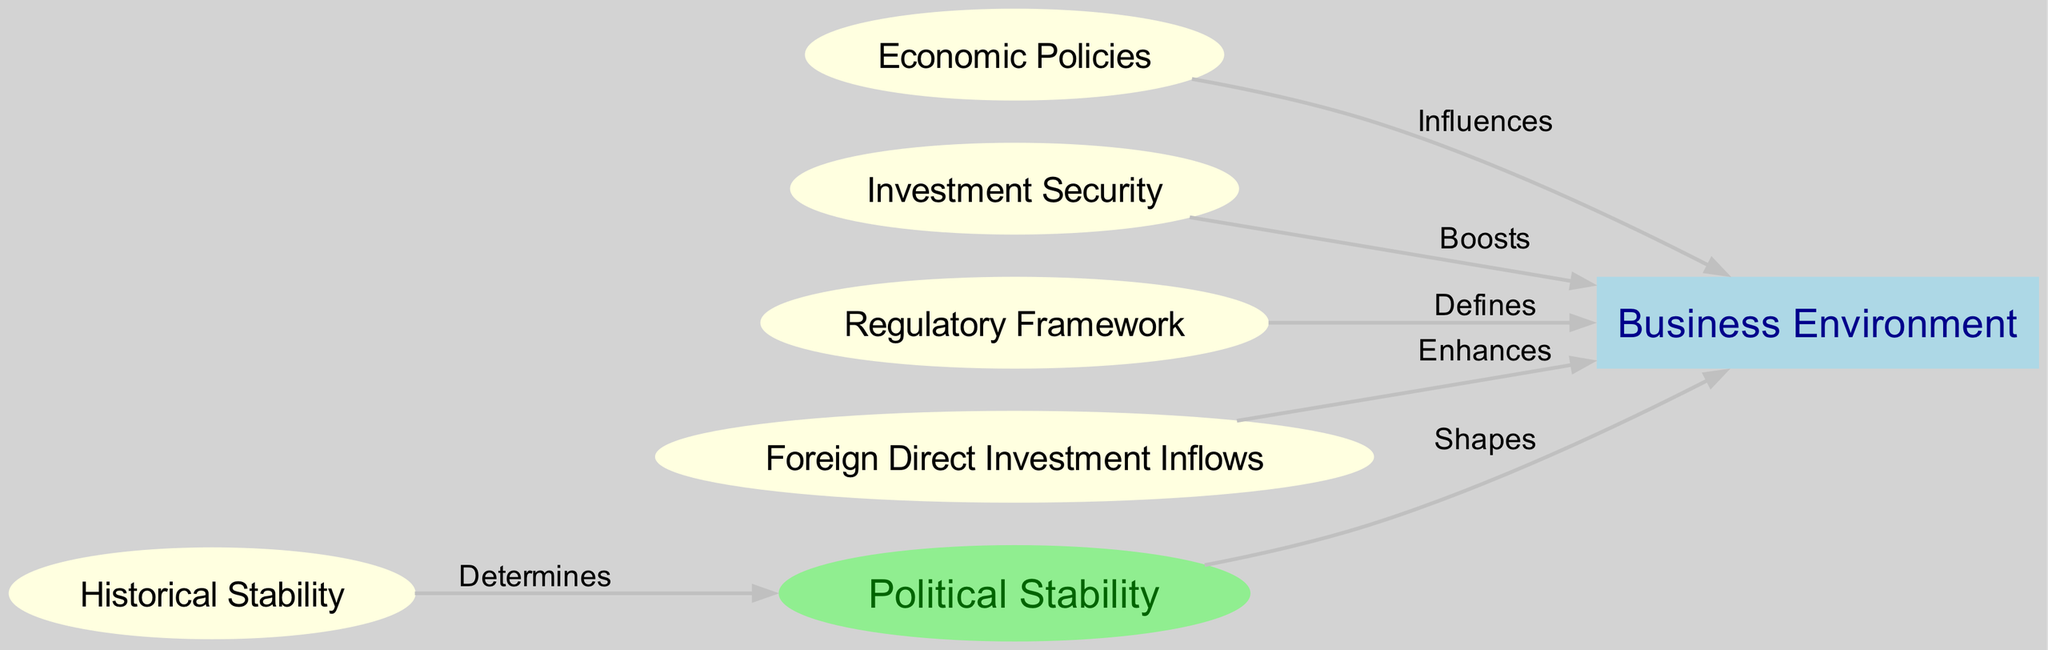What is the total number of nodes in the diagram? The diagram contains nodes representing "Political Stability", "Business Environment", "Economic Policies", "Investment Security", "Regulatory Framework", "Historical Stability", and "Foreign Direct Investment Inflows". Counting these, we find there are 7 nodes in total.
Answer: 7 Which node influences the Business Environment? According to the edges in the diagram, "Economic Policies" influences the "Business Environment". This is indicated by the label "Influences" on the edge between these two nodes.
Answer: Economic Policies How many edges connect to the Business Environment? By examining the edges in the diagram, we see that "Political Stability", "Economic Policies", "Investment Security", "Regulatory Framework", and "Foreign Direct Investment Inflows" all connect to "Business Environment", resulting in a total of 5 edges.
Answer: 5 What determines political stability? The relationship in the diagram shows that "Historical Stability" determines "Political Stability". This is represented by the edge labeled "Determines" that connects these two nodes.
Answer: Historical Stability Which node boosts the Business Environment? The edge labeled "Boosts" connecting "Investment Security" to "Business Environment" clearly indicates that "Investment Security" boosts the business environment.
Answer: Investment Security Which node directly shapes the Business Environment? The diagram indicates that "Political Stability" shapes the "Business Environment" through the edge labeled "Shapes". Therefore, the answer is "Political Stability".
Answer: Political Stability What type of relationship exists between Foreign Direct Investment Inflows and the Business Environment? The relationship shown in the diagram indicates that "Foreign Direct Investment Inflows" enhances the "Business Environment", as denoted by the edge labeled "Enhances".
Answer: Enhances What are the two nodes that define the Business Environment? The edges show that both "Regulatory Framework" and "Economic Policies" define the "Business Environment". This requires combining the relationships from both the regulatory and economic policy nodes to arrive at this conclusion.
Answer: Regulatory Framework, Economic Policies 